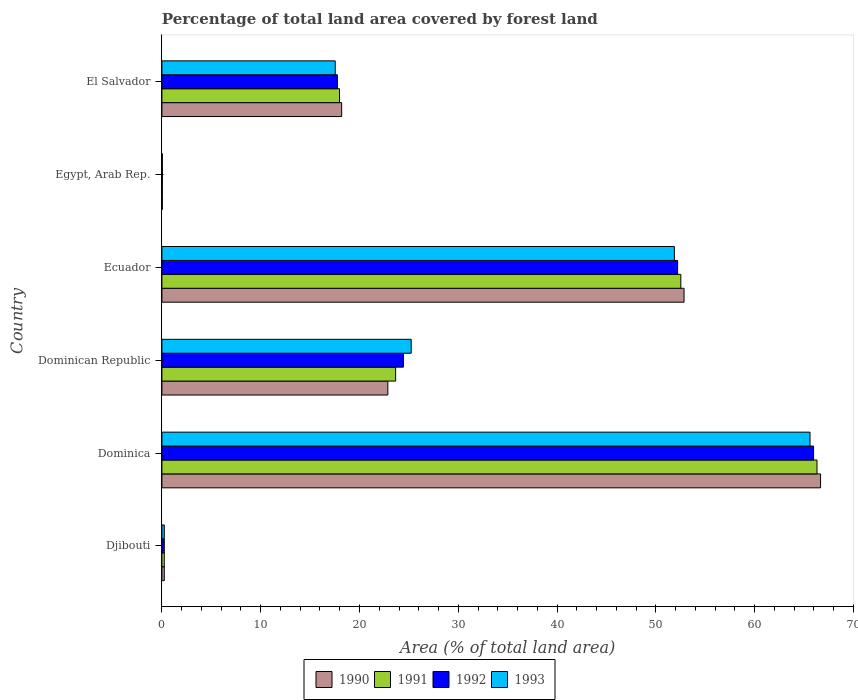How many different coloured bars are there?
Offer a terse response. 4. How many groups of bars are there?
Offer a terse response. 6. Are the number of bars per tick equal to the number of legend labels?
Keep it short and to the point. Yes. How many bars are there on the 4th tick from the top?
Your answer should be very brief. 4. How many bars are there on the 6th tick from the bottom?
Keep it short and to the point. 4. What is the label of the 1st group of bars from the top?
Provide a succinct answer. El Salvador. What is the percentage of forest land in 1990 in El Salvador?
Offer a very short reply. 18.19. Across all countries, what is the maximum percentage of forest land in 1990?
Offer a terse response. 66.67. Across all countries, what is the minimum percentage of forest land in 1993?
Keep it short and to the point. 0.05. In which country was the percentage of forest land in 1990 maximum?
Provide a short and direct response. Dominica. In which country was the percentage of forest land in 1993 minimum?
Your response must be concise. Egypt, Arab Rep. What is the total percentage of forest land in 1993 in the graph?
Offer a very short reply. 160.54. What is the difference between the percentage of forest land in 1993 in Dominican Republic and that in El Salvador?
Your answer should be very brief. 7.69. What is the difference between the percentage of forest land in 1993 in Dominica and the percentage of forest land in 1991 in Ecuador?
Ensure brevity in your answer.  13.08. What is the average percentage of forest land in 1993 per country?
Provide a succinct answer. 26.76. What is the difference between the percentage of forest land in 1991 and percentage of forest land in 1993 in Egypt, Arab Rep.?
Offer a terse response. -0. In how many countries, is the percentage of forest land in 1992 greater than 64 %?
Your response must be concise. 1. What is the ratio of the percentage of forest land in 1993 in Dominican Republic to that in Ecuador?
Offer a terse response. 0.49. Is the difference between the percentage of forest land in 1991 in Djibouti and Egypt, Arab Rep. greater than the difference between the percentage of forest land in 1993 in Djibouti and Egypt, Arab Rep.?
Ensure brevity in your answer.  Yes. What is the difference between the highest and the second highest percentage of forest land in 1991?
Your response must be concise. 13.78. What is the difference between the highest and the lowest percentage of forest land in 1991?
Offer a terse response. 66.26. Is it the case that in every country, the sum of the percentage of forest land in 1991 and percentage of forest land in 1993 is greater than the sum of percentage of forest land in 1990 and percentage of forest land in 1992?
Your response must be concise. No. What does the 3rd bar from the bottom in Dominica represents?
Offer a terse response. 1992. Is it the case that in every country, the sum of the percentage of forest land in 1993 and percentage of forest land in 1992 is greater than the percentage of forest land in 1990?
Your answer should be very brief. Yes. Are all the bars in the graph horizontal?
Your answer should be very brief. Yes. How many countries are there in the graph?
Ensure brevity in your answer.  6. What is the difference between two consecutive major ticks on the X-axis?
Your response must be concise. 10. Does the graph contain any zero values?
Provide a short and direct response. No. Does the graph contain grids?
Offer a very short reply. No. Where does the legend appear in the graph?
Provide a short and direct response. Bottom center. How are the legend labels stacked?
Your response must be concise. Horizontal. What is the title of the graph?
Provide a short and direct response. Percentage of total land area covered by forest land. What is the label or title of the X-axis?
Your answer should be very brief. Area (% of total land area). What is the Area (% of total land area) of 1990 in Djibouti?
Make the answer very short. 0.24. What is the Area (% of total land area) in 1991 in Djibouti?
Your response must be concise. 0.24. What is the Area (% of total land area) in 1992 in Djibouti?
Give a very brief answer. 0.24. What is the Area (% of total land area) of 1993 in Djibouti?
Keep it short and to the point. 0.24. What is the Area (% of total land area) in 1990 in Dominica?
Offer a very short reply. 66.67. What is the Area (% of total land area) in 1991 in Dominica?
Ensure brevity in your answer.  66.31. What is the Area (% of total land area) of 1992 in Dominica?
Your answer should be compact. 65.96. What is the Area (% of total land area) of 1993 in Dominica?
Provide a short and direct response. 65.6. What is the Area (% of total land area) of 1990 in Dominican Republic?
Your answer should be compact. 22.87. What is the Area (% of total land area) of 1991 in Dominican Republic?
Ensure brevity in your answer.  23.66. What is the Area (% of total land area) of 1992 in Dominican Republic?
Your response must be concise. 24.45. What is the Area (% of total land area) of 1993 in Dominican Republic?
Your response must be concise. 25.23. What is the Area (% of total land area) in 1990 in Ecuador?
Your answer should be very brief. 52.85. What is the Area (% of total land area) of 1991 in Ecuador?
Ensure brevity in your answer.  52.52. What is the Area (% of total land area) of 1992 in Ecuador?
Offer a terse response. 52.2. What is the Area (% of total land area) in 1993 in Ecuador?
Your response must be concise. 51.87. What is the Area (% of total land area) of 1990 in Egypt, Arab Rep.?
Make the answer very short. 0.04. What is the Area (% of total land area) of 1991 in Egypt, Arab Rep.?
Make the answer very short. 0.05. What is the Area (% of total land area) in 1992 in Egypt, Arab Rep.?
Your answer should be compact. 0.05. What is the Area (% of total land area) in 1993 in Egypt, Arab Rep.?
Provide a short and direct response. 0.05. What is the Area (% of total land area) of 1990 in El Salvador?
Offer a terse response. 18.19. What is the Area (% of total land area) of 1991 in El Salvador?
Ensure brevity in your answer.  17.98. What is the Area (% of total land area) in 1992 in El Salvador?
Offer a very short reply. 17.76. What is the Area (% of total land area) of 1993 in El Salvador?
Your answer should be compact. 17.54. Across all countries, what is the maximum Area (% of total land area) in 1990?
Your response must be concise. 66.67. Across all countries, what is the maximum Area (% of total land area) of 1991?
Keep it short and to the point. 66.31. Across all countries, what is the maximum Area (% of total land area) in 1992?
Your answer should be compact. 65.96. Across all countries, what is the maximum Area (% of total land area) of 1993?
Ensure brevity in your answer.  65.6. Across all countries, what is the minimum Area (% of total land area) of 1990?
Your answer should be very brief. 0.04. Across all countries, what is the minimum Area (% of total land area) in 1991?
Give a very brief answer. 0.05. Across all countries, what is the minimum Area (% of total land area) of 1992?
Keep it short and to the point. 0.05. Across all countries, what is the minimum Area (% of total land area) in 1993?
Provide a short and direct response. 0.05. What is the total Area (% of total land area) of 1990 in the graph?
Give a very brief answer. 160.87. What is the total Area (% of total land area) in 1991 in the graph?
Provide a short and direct response. 160.75. What is the total Area (% of total land area) in 1992 in the graph?
Your answer should be compact. 160.65. What is the total Area (% of total land area) of 1993 in the graph?
Ensure brevity in your answer.  160.54. What is the difference between the Area (% of total land area) of 1990 in Djibouti and that in Dominica?
Your response must be concise. -66.43. What is the difference between the Area (% of total land area) in 1991 in Djibouti and that in Dominica?
Provide a succinct answer. -66.07. What is the difference between the Area (% of total land area) in 1992 in Djibouti and that in Dominica?
Make the answer very short. -65.72. What is the difference between the Area (% of total land area) of 1993 in Djibouti and that in Dominica?
Make the answer very short. -65.36. What is the difference between the Area (% of total land area) of 1990 in Djibouti and that in Dominican Republic?
Make the answer very short. -22.63. What is the difference between the Area (% of total land area) in 1991 in Djibouti and that in Dominican Republic?
Provide a short and direct response. -23.42. What is the difference between the Area (% of total land area) of 1992 in Djibouti and that in Dominican Republic?
Keep it short and to the point. -24.2. What is the difference between the Area (% of total land area) in 1993 in Djibouti and that in Dominican Republic?
Ensure brevity in your answer.  -24.99. What is the difference between the Area (% of total land area) of 1990 in Djibouti and that in Ecuador?
Your response must be concise. -52.61. What is the difference between the Area (% of total land area) of 1991 in Djibouti and that in Ecuador?
Keep it short and to the point. -52.28. What is the difference between the Area (% of total land area) of 1992 in Djibouti and that in Ecuador?
Offer a terse response. -51.96. What is the difference between the Area (% of total land area) of 1993 in Djibouti and that in Ecuador?
Your response must be concise. -51.63. What is the difference between the Area (% of total land area) in 1990 in Djibouti and that in Egypt, Arab Rep.?
Your answer should be compact. 0.2. What is the difference between the Area (% of total land area) of 1991 in Djibouti and that in Egypt, Arab Rep.?
Provide a short and direct response. 0.2. What is the difference between the Area (% of total land area) of 1992 in Djibouti and that in Egypt, Arab Rep.?
Provide a short and direct response. 0.19. What is the difference between the Area (% of total land area) of 1993 in Djibouti and that in Egypt, Arab Rep.?
Provide a succinct answer. 0.19. What is the difference between the Area (% of total land area) in 1990 in Djibouti and that in El Salvador?
Your answer should be compact. -17.95. What is the difference between the Area (% of total land area) in 1991 in Djibouti and that in El Salvador?
Provide a short and direct response. -17.74. What is the difference between the Area (% of total land area) in 1992 in Djibouti and that in El Salvador?
Keep it short and to the point. -17.52. What is the difference between the Area (% of total land area) of 1993 in Djibouti and that in El Salvador?
Ensure brevity in your answer.  -17.3. What is the difference between the Area (% of total land area) in 1990 in Dominica and that in Dominican Republic?
Ensure brevity in your answer.  43.8. What is the difference between the Area (% of total land area) of 1991 in Dominica and that in Dominican Republic?
Your answer should be compact. 42.65. What is the difference between the Area (% of total land area) in 1992 in Dominica and that in Dominican Republic?
Provide a short and direct response. 41.51. What is the difference between the Area (% of total land area) of 1993 in Dominica and that in Dominican Republic?
Provide a succinct answer. 40.37. What is the difference between the Area (% of total land area) of 1990 in Dominica and that in Ecuador?
Give a very brief answer. 13.82. What is the difference between the Area (% of total land area) in 1991 in Dominica and that in Ecuador?
Provide a succinct answer. 13.78. What is the difference between the Area (% of total land area) of 1992 in Dominica and that in Ecuador?
Provide a succinct answer. 13.76. What is the difference between the Area (% of total land area) in 1993 in Dominica and that in Ecuador?
Keep it short and to the point. 13.73. What is the difference between the Area (% of total land area) in 1990 in Dominica and that in Egypt, Arab Rep.?
Keep it short and to the point. 66.62. What is the difference between the Area (% of total land area) of 1991 in Dominica and that in Egypt, Arab Rep.?
Make the answer very short. 66.26. What is the difference between the Area (% of total land area) in 1992 in Dominica and that in Egypt, Arab Rep.?
Keep it short and to the point. 65.91. What is the difference between the Area (% of total land area) of 1993 in Dominica and that in Egypt, Arab Rep.?
Offer a very short reply. 65.55. What is the difference between the Area (% of total land area) of 1990 in Dominica and that in El Salvador?
Provide a short and direct response. 48.47. What is the difference between the Area (% of total land area) in 1991 in Dominica and that in El Salvador?
Your response must be concise. 48.33. What is the difference between the Area (% of total land area) of 1992 in Dominica and that in El Salvador?
Provide a succinct answer. 48.2. What is the difference between the Area (% of total land area) in 1993 in Dominica and that in El Salvador?
Make the answer very short. 48.06. What is the difference between the Area (% of total land area) of 1990 in Dominican Republic and that in Ecuador?
Your answer should be compact. -29.98. What is the difference between the Area (% of total land area) in 1991 in Dominican Republic and that in Ecuador?
Keep it short and to the point. -28.87. What is the difference between the Area (% of total land area) in 1992 in Dominican Republic and that in Ecuador?
Provide a short and direct response. -27.75. What is the difference between the Area (% of total land area) in 1993 in Dominican Republic and that in Ecuador?
Your answer should be very brief. -26.64. What is the difference between the Area (% of total land area) in 1990 in Dominican Republic and that in Egypt, Arab Rep.?
Give a very brief answer. 22.82. What is the difference between the Area (% of total land area) in 1991 in Dominican Republic and that in Egypt, Arab Rep.?
Offer a terse response. 23.61. What is the difference between the Area (% of total land area) of 1992 in Dominican Republic and that in Egypt, Arab Rep.?
Ensure brevity in your answer.  24.4. What is the difference between the Area (% of total land area) in 1993 in Dominican Republic and that in Egypt, Arab Rep.?
Provide a succinct answer. 25.19. What is the difference between the Area (% of total land area) in 1990 in Dominican Republic and that in El Salvador?
Offer a very short reply. 4.67. What is the difference between the Area (% of total land area) of 1991 in Dominican Republic and that in El Salvador?
Provide a succinct answer. 5.68. What is the difference between the Area (% of total land area) of 1992 in Dominican Republic and that in El Salvador?
Your answer should be very brief. 6.68. What is the difference between the Area (% of total land area) of 1993 in Dominican Republic and that in El Salvador?
Your answer should be compact. 7.69. What is the difference between the Area (% of total land area) in 1990 in Ecuador and that in Egypt, Arab Rep.?
Offer a very short reply. 52.81. What is the difference between the Area (% of total land area) of 1991 in Ecuador and that in Egypt, Arab Rep.?
Give a very brief answer. 52.48. What is the difference between the Area (% of total land area) in 1992 in Ecuador and that in Egypt, Arab Rep.?
Make the answer very short. 52.15. What is the difference between the Area (% of total land area) in 1993 in Ecuador and that in Egypt, Arab Rep.?
Offer a terse response. 51.82. What is the difference between the Area (% of total land area) of 1990 in Ecuador and that in El Salvador?
Provide a succinct answer. 34.65. What is the difference between the Area (% of total land area) of 1991 in Ecuador and that in El Salvador?
Offer a terse response. 34.55. What is the difference between the Area (% of total land area) in 1992 in Ecuador and that in El Salvador?
Your response must be concise. 34.44. What is the difference between the Area (% of total land area) in 1993 in Ecuador and that in El Salvador?
Your answer should be compact. 34.33. What is the difference between the Area (% of total land area) in 1990 in Egypt, Arab Rep. and that in El Salvador?
Provide a succinct answer. -18.15. What is the difference between the Area (% of total land area) of 1991 in Egypt, Arab Rep. and that in El Salvador?
Your response must be concise. -17.93. What is the difference between the Area (% of total land area) in 1992 in Egypt, Arab Rep. and that in El Salvador?
Offer a terse response. -17.71. What is the difference between the Area (% of total land area) of 1993 in Egypt, Arab Rep. and that in El Salvador?
Your response must be concise. -17.49. What is the difference between the Area (% of total land area) of 1990 in Djibouti and the Area (% of total land area) of 1991 in Dominica?
Offer a very short reply. -66.07. What is the difference between the Area (% of total land area) of 1990 in Djibouti and the Area (% of total land area) of 1992 in Dominica?
Offer a very short reply. -65.72. What is the difference between the Area (% of total land area) in 1990 in Djibouti and the Area (% of total land area) in 1993 in Dominica?
Ensure brevity in your answer.  -65.36. What is the difference between the Area (% of total land area) in 1991 in Djibouti and the Area (% of total land area) in 1992 in Dominica?
Your answer should be very brief. -65.72. What is the difference between the Area (% of total land area) in 1991 in Djibouti and the Area (% of total land area) in 1993 in Dominica?
Your answer should be very brief. -65.36. What is the difference between the Area (% of total land area) in 1992 in Djibouti and the Area (% of total land area) in 1993 in Dominica?
Your answer should be compact. -65.36. What is the difference between the Area (% of total land area) of 1990 in Djibouti and the Area (% of total land area) of 1991 in Dominican Republic?
Offer a terse response. -23.42. What is the difference between the Area (% of total land area) in 1990 in Djibouti and the Area (% of total land area) in 1992 in Dominican Republic?
Make the answer very short. -24.2. What is the difference between the Area (% of total land area) of 1990 in Djibouti and the Area (% of total land area) of 1993 in Dominican Republic?
Your answer should be compact. -24.99. What is the difference between the Area (% of total land area) of 1991 in Djibouti and the Area (% of total land area) of 1992 in Dominican Republic?
Make the answer very short. -24.2. What is the difference between the Area (% of total land area) in 1991 in Djibouti and the Area (% of total land area) in 1993 in Dominican Republic?
Keep it short and to the point. -24.99. What is the difference between the Area (% of total land area) in 1992 in Djibouti and the Area (% of total land area) in 1993 in Dominican Republic?
Ensure brevity in your answer.  -24.99. What is the difference between the Area (% of total land area) in 1990 in Djibouti and the Area (% of total land area) in 1991 in Ecuador?
Keep it short and to the point. -52.28. What is the difference between the Area (% of total land area) in 1990 in Djibouti and the Area (% of total land area) in 1992 in Ecuador?
Provide a short and direct response. -51.96. What is the difference between the Area (% of total land area) in 1990 in Djibouti and the Area (% of total land area) in 1993 in Ecuador?
Your answer should be compact. -51.63. What is the difference between the Area (% of total land area) of 1991 in Djibouti and the Area (% of total land area) of 1992 in Ecuador?
Keep it short and to the point. -51.96. What is the difference between the Area (% of total land area) of 1991 in Djibouti and the Area (% of total land area) of 1993 in Ecuador?
Ensure brevity in your answer.  -51.63. What is the difference between the Area (% of total land area) in 1992 in Djibouti and the Area (% of total land area) in 1993 in Ecuador?
Offer a very short reply. -51.63. What is the difference between the Area (% of total land area) of 1990 in Djibouti and the Area (% of total land area) of 1991 in Egypt, Arab Rep.?
Provide a short and direct response. 0.2. What is the difference between the Area (% of total land area) in 1990 in Djibouti and the Area (% of total land area) in 1992 in Egypt, Arab Rep.?
Offer a terse response. 0.19. What is the difference between the Area (% of total land area) of 1990 in Djibouti and the Area (% of total land area) of 1993 in Egypt, Arab Rep.?
Keep it short and to the point. 0.19. What is the difference between the Area (% of total land area) of 1991 in Djibouti and the Area (% of total land area) of 1992 in Egypt, Arab Rep.?
Provide a short and direct response. 0.19. What is the difference between the Area (% of total land area) of 1991 in Djibouti and the Area (% of total land area) of 1993 in Egypt, Arab Rep.?
Your answer should be compact. 0.19. What is the difference between the Area (% of total land area) of 1992 in Djibouti and the Area (% of total land area) of 1993 in Egypt, Arab Rep.?
Give a very brief answer. 0.19. What is the difference between the Area (% of total land area) of 1990 in Djibouti and the Area (% of total land area) of 1991 in El Salvador?
Keep it short and to the point. -17.74. What is the difference between the Area (% of total land area) of 1990 in Djibouti and the Area (% of total land area) of 1992 in El Salvador?
Ensure brevity in your answer.  -17.52. What is the difference between the Area (% of total land area) of 1990 in Djibouti and the Area (% of total land area) of 1993 in El Salvador?
Offer a very short reply. -17.3. What is the difference between the Area (% of total land area) of 1991 in Djibouti and the Area (% of total land area) of 1992 in El Salvador?
Provide a short and direct response. -17.52. What is the difference between the Area (% of total land area) in 1991 in Djibouti and the Area (% of total land area) in 1993 in El Salvador?
Provide a short and direct response. -17.3. What is the difference between the Area (% of total land area) of 1992 in Djibouti and the Area (% of total land area) of 1993 in El Salvador?
Your answer should be compact. -17.3. What is the difference between the Area (% of total land area) of 1990 in Dominica and the Area (% of total land area) of 1991 in Dominican Republic?
Provide a succinct answer. 43.01. What is the difference between the Area (% of total land area) in 1990 in Dominica and the Area (% of total land area) in 1992 in Dominican Republic?
Give a very brief answer. 42.22. What is the difference between the Area (% of total land area) of 1990 in Dominica and the Area (% of total land area) of 1993 in Dominican Republic?
Offer a very short reply. 41.43. What is the difference between the Area (% of total land area) of 1991 in Dominica and the Area (% of total land area) of 1992 in Dominican Republic?
Make the answer very short. 41.86. What is the difference between the Area (% of total land area) of 1991 in Dominica and the Area (% of total land area) of 1993 in Dominican Republic?
Keep it short and to the point. 41.07. What is the difference between the Area (% of total land area) in 1992 in Dominica and the Area (% of total land area) in 1993 in Dominican Republic?
Give a very brief answer. 40.73. What is the difference between the Area (% of total land area) of 1990 in Dominica and the Area (% of total land area) of 1991 in Ecuador?
Make the answer very short. 14.14. What is the difference between the Area (% of total land area) in 1990 in Dominica and the Area (% of total land area) in 1992 in Ecuador?
Offer a terse response. 14.47. What is the difference between the Area (% of total land area) in 1990 in Dominica and the Area (% of total land area) in 1993 in Ecuador?
Ensure brevity in your answer.  14.79. What is the difference between the Area (% of total land area) in 1991 in Dominica and the Area (% of total land area) in 1992 in Ecuador?
Offer a very short reply. 14.11. What is the difference between the Area (% of total land area) of 1991 in Dominica and the Area (% of total land area) of 1993 in Ecuador?
Your answer should be compact. 14.43. What is the difference between the Area (% of total land area) of 1992 in Dominica and the Area (% of total land area) of 1993 in Ecuador?
Provide a short and direct response. 14.09. What is the difference between the Area (% of total land area) in 1990 in Dominica and the Area (% of total land area) in 1991 in Egypt, Arab Rep.?
Your response must be concise. 66.62. What is the difference between the Area (% of total land area) in 1990 in Dominica and the Area (% of total land area) in 1992 in Egypt, Arab Rep.?
Your answer should be very brief. 66.62. What is the difference between the Area (% of total land area) of 1990 in Dominica and the Area (% of total land area) of 1993 in Egypt, Arab Rep.?
Give a very brief answer. 66.62. What is the difference between the Area (% of total land area) of 1991 in Dominica and the Area (% of total land area) of 1992 in Egypt, Arab Rep.?
Ensure brevity in your answer.  66.26. What is the difference between the Area (% of total land area) of 1991 in Dominica and the Area (% of total land area) of 1993 in Egypt, Arab Rep.?
Keep it short and to the point. 66.26. What is the difference between the Area (% of total land area) of 1992 in Dominica and the Area (% of total land area) of 1993 in Egypt, Arab Rep.?
Provide a succinct answer. 65.91. What is the difference between the Area (% of total land area) in 1990 in Dominica and the Area (% of total land area) in 1991 in El Salvador?
Offer a terse response. 48.69. What is the difference between the Area (% of total land area) in 1990 in Dominica and the Area (% of total land area) in 1992 in El Salvador?
Give a very brief answer. 48.91. What is the difference between the Area (% of total land area) of 1990 in Dominica and the Area (% of total land area) of 1993 in El Salvador?
Offer a very short reply. 49.12. What is the difference between the Area (% of total land area) of 1991 in Dominica and the Area (% of total land area) of 1992 in El Salvador?
Offer a terse response. 48.55. What is the difference between the Area (% of total land area) of 1991 in Dominica and the Area (% of total land area) of 1993 in El Salvador?
Ensure brevity in your answer.  48.76. What is the difference between the Area (% of total land area) in 1992 in Dominica and the Area (% of total land area) in 1993 in El Salvador?
Offer a very short reply. 48.42. What is the difference between the Area (% of total land area) in 1990 in Dominican Republic and the Area (% of total land area) in 1991 in Ecuador?
Ensure brevity in your answer.  -29.66. What is the difference between the Area (% of total land area) of 1990 in Dominican Republic and the Area (% of total land area) of 1992 in Ecuador?
Your answer should be very brief. -29.33. What is the difference between the Area (% of total land area) in 1990 in Dominican Republic and the Area (% of total land area) in 1993 in Ecuador?
Your answer should be very brief. -29. What is the difference between the Area (% of total land area) of 1991 in Dominican Republic and the Area (% of total land area) of 1992 in Ecuador?
Your response must be concise. -28.54. What is the difference between the Area (% of total land area) in 1991 in Dominican Republic and the Area (% of total land area) in 1993 in Ecuador?
Ensure brevity in your answer.  -28.22. What is the difference between the Area (% of total land area) in 1992 in Dominican Republic and the Area (% of total land area) in 1993 in Ecuador?
Give a very brief answer. -27.43. What is the difference between the Area (% of total land area) in 1990 in Dominican Republic and the Area (% of total land area) in 1991 in Egypt, Arab Rep.?
Your answer should be compact. 22.82. What is the difference between the Area (% of total land area) of 1990 in Dominican Republic and the Area (% of total land area) of 1992 in Egypt, Arab Rep.?
Offer a terse response. 22.82. What is the difference between the Area (% of total land area) of 1990 in Dominican Republic and the Area (% of total land area) of 1993 in Egypt, Arab Rep.?
Keep it short and to the point. 22.82. What is the difference between the Area (% of total land area) in 1991 in Dominican Republic and the Area (% of total land area) in 1992 in Egypt, Arab Rep.?
Your answer should be very brief. 23.61. What is the difference between the Area (% of total land area) in 1991 in Dominican Republic and the Area (% of total land area) in 1993 in Egypt, Arab Rep.?
Offer a very short reply. 23.61. What is the difference between the Area (% of total land area) of 1992 in Dominican Republic and the Area (% of total land area) of 1993 in Egypt, Arab Rep.?
Give a very brief answer. 24.4. What is the difference between the Area (% of total land area) of 1990 in Dominican Republic and the Area (% of total land area) of 1991 in El Salvador?
Ensure brevity in your answer.  4.89. What is the difference between the Area (% of total land area) of 1990 in Dominican Republic and the Area (% of total land area) of 1992 in El Salvador?
Offer a terse response. 5.11. What is the difference between the Area (% of total land area) of 1990 in Dominican Republic and the Area (% of total land area) of 1993 in El Salvador?
Give a very brief answer. 5.32. What is the difference between the Area (% of total land area) of 1991 in Dominican Republic and the Area (% of total land area) of 1992 in El Salvador?
Keep it short and to the point. 5.9. What is the difference between the Area (% of total land area) of 1991 in Dominican Republic and the Area (% of total land area) of 1993 in El Salvador?
Provide a succinct answer. 6.11. What is the difference between the Area (% of total land area) of 1992 in Dominican Republic and the Area (% of total land area) of 1993 in El Salvador?
Offer a terse response. 6.9. What is the difference between the Area (% of total land area) of 1990 in Ecuador and the Area (% of total land area) of 1991 in Egypt, Arab Rep.?
Your answer should be very brief. 52.8. What is the difference between the Area (% of total land area) of 1990 in Ecuador and the Area (% of total land area) of 1992 in Egypt, Arab Rep.?
Your answer should be compact. 52.8. What is the difference between the Area (% of total land area) of 1990 in Ecuador and the Area (% of total land area) of 1993 in Egypt, Arab Rep.?
Offer a terse response. 52.8. What is the difference between the Area (% of total land area) in 1991 in Ecuador and the Area (% of total land area) in 1992 in Egypt, Arab Rep.?
Provide a short and direct response. 52.48. What is the difference between the Area (% of total land area) of 1991 in Ecuador and the Area (% of total land area) of 1993 in Egypt, Arab Rep.?
Offer a very short reply. 52.47. What is the difference between the Area (% of total land area) in 1992 in Ecuador and the Area (% of total land area) in 1993 in Egypt, Arab Rep.?
Provide a succinct answer. 52.15. What is the difference between the Area (% of total land area) in 1990 in Ecuador and the Area (% of total land area) in 1991 in El Salvador?
Your response must be concise. 34.87. What is the difference between the Area (% of total land area) of 1990 in Ecuador and the Area (% of total land area) of 1992 in El Salvador?
Ensure brevity in your answer.  35.09. What is the difference between the Area (% of total land area) of 1990 in Ecuador and the Area (% of total land area) of 1993 in El Salvador?
Provide a short and direct response. 35.31. What is the difference between the Area (% of total land area) in 1991 in Ecuador and the Area (% of total land area) in 1992 in El Salvador?
Your answer should be compact. 34.76. What is the difference between the Area (% of total land area) in 1991 in Ecuador and the Area (% of total land area) in 1993 in El Salvador?
Provide a succinct answer. 34.98. What is the difference between the Area (% of total land area) of 1992 in Ecuador and the Area (% of total land area) of 1993 in El Salvador?
Your answer should be compact. 34.65. What is the difference between the Area (% of total land area) in 1990 in Egypt, Arab Rep. and the Area (% of total land area) in 1991 in El Salvador?
Your answer should be very brief. -17.93. What is the difference between the Area (% of total land area) in 1990 in Egypt, Arab Rep. and the Area (% of total land area) in 1992 in El Salvador?
Offer a very short reply. -17.72. What is the difference between the Area (% of total land area) in 1990 in Egypt, Arab Rep. and the Area (% of total land area) in 1993 in El Salvador?
Keep it short and to the point. -17.5. What is the difference between the Area (% of total land area) in 1991 in Egypt, Arab Rep. and the Area (% of total land area) in 1992 in El Salvador?
Make the answer very short. -17.71. What is the difference between the Area (% of total land area) of 1991 in Egypt, Arab Rep. and the Area (% of total land area) of 1993 in El Salvador?
Offer a very short reply. -17.5. What is the difference between the Area (% of total land area) in 1992 in Egypt, Arab Rep. and the Area (% of total land area) in 1993 in El Salvador?
Ensure brevity in your answer.  -17.5. What is the average Area (% of total land area) in 1990 per country?
Offer a very short reply. 26.81. What is the average Area (% of total land area) of 1991 per country?
Offer a terse response. 26.79. What is the average Area (% of total land area) in 1992 per country?
Make the answer very short. 26.78. What is the average Area (% of total land area) of 1993 per country?
Ensure brevity in your answer.  26.76. What is the difference between the Area (% of total land area) of 1990 and Area (% of total land area) of 1991 in Djibouti?
Ensure brevity in your answer.  0. What is the difference between the Area (% of total land area) in 1990 and Area (% of total land area) in 1993 in Djibouti?
Your answer should be very brief. 0. What is the difference between the Area (% of total land area) in 1990 and Area (% of total land area) in 1991 in Dominica?
Ensure brevity in your answer.  0.36. What is the difference between the Area (% of total land area) in 1990 and Area (% of total land area) in 1992 in Dominica?
Keep it short and to the point. 0.71. What is the difference between the Area (% of total land area) of 1990 and Area (% of total land area) of 1993 in Dominica?
Ensure brevity in your answer.  1.07. What is the difference between the Area (% of total land area) of 1991 and Area (% of total land area) of 1992 in Dominica?
Your answer should be very brief. 0.35. What is the difference between the Area (% of total land area) in 1991 and Area (% of total land area) in 1993 in Dominica?
Ensure brevity in your answer.  0.71. What is the difference between the Area (% of total land area) of 1992 and Area (% of total land area) of 1993 in Dominica?
Make the answer very short. 0.36. What is the difference between the Area (% of total land area) of 1990 and Area (% of total land area) of 1991 in Dominican Republic?
Your response must be concise. -0.79. What is the difference between the Area (% of total land area) in 1990 and Area (% of total land area) in 1992 in Dominican Republic?
Offer a terse response. -1.58. What is the difference between the Area (% of total land area) in 1990 and Area (% of total land area) in 1993 in Dominican Republic?
Provide a succinct answer. -2.37. What is the difference between the Area (% of total land area) in 1991 and Area (% of total land area) in 1992 in Dominican Republic?
Offer a very short reply. -0.79. What is the difference between the Area (% of total land area) in 1991 and Area (% of total land area) in 1993 in Dominican Republic?
Provide a short and direct response. -1.58. What is the difference between the Area (% of total land area) in 1992 and Area (% of total land area) in 1993 in Dominican Republic?
Your answer should be compact. -0.79. What is the difference between the Area (% of total land area) in 1990 and Area (% of total land area) in 1991 in Ecuador?
Offer a terse response. 0.33. What is the difference between the Area (% of total land area) of 1990 and Area (% of total land area) of 1992 in Ecuador?
Your response must be concise. 0.65. What is the difference between the Area (% of total land area) of 1990 and Area (% of total land area) of 1993 in Ecuador?
Make the answer very short. 0.98. What is the difference between the Area (% of total land area) in 1991 and Area (% of total land area) in 1992 in Ecuador?
Ensure brevity in your answer.  0.33. What is the difference between the Area (% of total land area) in 1991 and Area (% of total land area) in 1993 in Ecuador?
Keep it short and to the point. 0.65. What is the difference between the Area (% of total land area) of 1992 and Area (% of total land area) of 1993 in Ecuador?
Ensure brevity in your answer.  0.33. What is the difference between the Area (% of total land area) in 1990 and Area (% of total land area) in 1991 in Egypt, Arab Rep.?
Offer a terse response. -0. What is the difference between the Area (% of total land area) in 1990 and Area (% of total land area) in 1992 in Egypt, Arab Rep.?
Make the answer very short. -0. What is the difference between the Area (% of total land area) in 1990 and Area (% of total land area) in 1993 in Egypt, Arab Rep.?
Give a very brief answer. -0. What is the difference between the Area (% of total land area) of 1991 and Area (% of total land area) of 1992 in Egypt, Arab Rep.?
Make the answer very short. -0. What is the difference between the Area (% of total land area) in 1991 and Area (% of total land area) in 1993 in Egypt, Arab Rep.?
Give a very brief answer. -0. What is the difference between the Area (% of total land area) in 1992 and Area (% of total land area) in 1993 in Egypt, Arab Rep.?
Ensure brevity in your answer.  -0. What is the difference between the Area (% of total land area) of 1990 and Area (% of total land area) of 1991 in El Salvador?
Your response must be concise. 0.22. What is the difference between the Area (% of total land area) in 1990 and Area (% of total land area) in 1992 in El Salvador?
Your response must be concise. 0.43. What is the difference between the Area (% of total land area) in 1990 and Area (% of total land area) in 1993 in El Salvador?
Provide a short and direct response. 0.65. What is the difference between the Area (% of total land area) of 1991 and Area (% of total land area) of 1992 in El Salvador?
Your response must be concise. 0.22. What is the difference between the Area (% of total land area) of 1991 and Area (% of total land area) of 1993 in El Salvador?
Your response must be concise. 0.43. What is the difference between the Area (% of total land area) in 1992 and Area (% of total land area) in 1993 in El Salvador?
Offer a very short reply. 0.22. What is the ratio of the Area (% of total land area) in 1990 in Djibouti to that in Dominica?
Provide a short and direct response. 0. What is the ratio of the Area (% of total land area) in 1991 in Djibouti to that in Dominica?
Keep it short and to the point. 0. What is the ratio of the Area (% of total land area) in 1992 in Djibouti to that in Dominica?
Give a very brief answer. 0. What is the ratio of the Area (% of total land area) in 1993 in Djibouti to that in Dominica?
Provide a succinct answer. 0. What is the ratio of the Area (% of total land area) of 1990 in Djibouti to that in Dominican Republic?
Ensure brevity in your answer.  0.01. What is the ratio of the Area (% of total land area) in 1991 in Djibouti to that in Dominican Republic?
Provide a succinct answer. 0.01. What is the ratio of the Area (% of total land area) in 1992 in Djibouti to that in Dominican Republic?
Your answer should be very brief. 0.01. What is the ratio of the Area (% of total land area) of 1993 in Djibouti to that in Dominican Republic?
Offer a terse response. 0.01. What is the ratio of the Area (% of total land area) of 1990 in Djibouti to that in Ecuador?
Your answer should be compact. 0. What is the ratio of the Area (% of total land area) of 1991 in Djibouti to that in Ecuador?
Give a very brief answer. 0. What is the ratio of the Area (% of total land area) of 1992 in Djibouti to that in Ecuador?
Provide a short and direct response. 0. What is the ratio of the Area (% of total land area) of 1993 in Djibouti to that in Ecuador?
Ensure brevity in your answer.  0. What is the ratio of the Area (% of total land area) of 1990 in Djibouti to that in Egypt, Arab Rep.?
Make the answer very short. 5.47. What is the ratio of the Area (% of total land area) in 1991 in Djibouti to that in Egypt, Arab Rep.?
Give a very brief answer. 5.29. What is the ratio of the Area (% of total land area) of 1992 in Djibouti to that in Egypt, Arab Rep.?
Provide a short and direct response. 5.12. What is the ratio of the Area (% of total land area) in 1993 in Djibouti to that in Egypt, Arab Rep.?
Keep it short and to the point. 4.96. What is the ratio of the Area (% of total land area) in 1990 in Djibouti to that in El Salvador?
Keep it short and to the point. 0.01. What is the ratio of the Area (% of total land area) in 1991 in Djibouti to that in El Salvador?
Ensure brevity in your answer.  0.01. What is the ratio of the Area (% of total land area) of 1992 in Djibouti to that in El Salvador?
Offer a terse response. 0.01. What is the ratio of the Area (% of total land area) in 1993 in Djibouti to that in El Salvador?
Make the answer very short. 0.01. What is the ratio of the Area (% of total land area) of 1990 in Dominica to that in Dominican Republic?
Your answer should be compact. 2.92. What is the ratio of the Area (% of total land area) in 1991 in Dominica to that in Dominican Republic?
Provide a succinct answer. 2.8. What is the ratio of the Area (% of total land area) in 1992 in Dominica to that in Dominican Republic?
Ensure brevity in your answer.  2.7. What is the ratio of the Area (% of total land area) of 1993 in Dominica to that in Dominican Republic?
Your answer should be very brief. 2.6. What is the ratio of the Area (% of total land area) in 1990 in Dominica to that in Ecuador?
Offer a terse response. 1.26. What is the ratio of the Area (% of total land area) of 1991 in Dominica to that in Ecuador?
Offer a very short reply. 1.26. What is the ratio of the Area (% of total land area) in 1992 in Dominica to that in Ecuador?
Give a very brief answer. 1.26. What is the ratio of the Area (% of total land area) in 1993 in Dominica to that in Ecuador?
Your answer should be compact. 1.26. What is the ratio of the Area (% of total land area) of 1990 in Dominica to that in Egypt, Arab Rep.?
Your answer should be very brief. 1508.26. What is the ratio of the Area (% of total land area) in 1991 in Dominica to that in Egypt, Arab Rep.?
Your response must be concise. 1450.66. What is the ratio of the Area (% of total land area) of 1992 in Dominica to that in Egypt, Arab Rep.?
Give a very brief answer. 1397.02. What is the ratio of the Area (% of total land area) in 1993 in Dominica to that in Egypt, Arab Rep.?
Ensure brevity in your answer.  1346.42. What is the ratio of the Area (% of total land area) in 1990 in Dominica to that in El Salvador?
Offer a terse response. 3.66. What is the ratio of the Area (% of total land area) in 1991 in Dominica to that in El Salvador?
Give a very brief answer. 3.69. What is the ratio of the Area (% of total land area) of 1992 in Dominica to that in El Salvador?
Give a very brief answer. 3.71. What is the ratio of the Area (% of total land area) of 1993 in Dominica to that in El Salvador?
Offer a terse response. 3.74. What is the ratio of the Area (% of total land area) in 1990 in Dominican Republic to that in Ecuador?
Your answer should be compact. 0.43. What is the ratio of the Area (% of total land area) in 1991 in Dominican Republic to that in Ecuador?
Keep it short and to the point. 0.45. What is the ratio of the Area (% of total land area) of 1992 in Dominican Republic to that in Ecuador?
Provide a succinct answer. 0.47. What is the ratio of the Area (% of total land area) of 1993 in Dominican Republic to that in Ecuador?
Provide a short and direct response. 0.49. What is the ratio of the Area (% of total land area) in 1990 in Dominican Republic to that in Egypt, Arab Rep.?
Keep it short and to the point. 517.37. What is the ratio of the Area (% of total land area) in 1991 in Dominican Republic to that in Egypt, Arab Rep.?
Provide a succinct answer. 517.57. What is the ratio of the Area (% of total land area) of 1992 in Dominican Republic to that in Egypt, Arab Rep.?
Your answer should be compact. 517.75. What is the ratio of the Area (% of total land area) of 1993 in Dominican Republic to that in Egypt, Arab Rep.?
Your answer should be compact. 517.92. What is the ratio of the Area (% of total land area) in 1990 in Dominican Republic to that in El Salvador?
Provide a short and direct response. 1.26. What is the ratio of the Area (% of total land area) of 1991 in Dominican Republic to that in El Salvador?
Make the answer very short. 1.32. What is the ratio of the Area (% of total land area) of 1992 in Dominican Republic to that in El Salvador?
Offer a very short reply. 1.38. What is the ratio of the Area (% of total land area) of 1993 in Dominican Republic to that in El Salvador?
Your answer should be compact. 1.44. What is the ratio of the Area (% of total land area) of 1990 in Ecuador to that in Egypt, Arab Rep.?
Provide a succinct answer. 1195.66. What is the ratio of the Area (% of total land area) in 1991 in Ecuador to that in Egypt, Arab Rep.?
Give a very brief answer. 1149.11. What is the ratio of the Area (% of total land area) of 1992 in Ecuador to that in Egypt, Arab Rep.?
Offer a terse response. 1105.54. What is the ratio of the Area (% of total land area) of 1993 in Ecuador to that in Egypt, Arab Rep.?
Your answer should be compact. 1064.66. What is the ratio of the Area (% of total land area) of 1990 in Ecuador to that in El Salvador?
Give a very brief answer. 2.9. What is the ratio of the Area (% of total land area) in 1991 in Ecuador to that in El Salvador?
Provide a succinct answer. 2.92. What is the ratio of the Area (% of total land area) of 1992 in Ecuador to that in El Salvador?
Offer a terse response. 2.94. What is the ratio of the Area (% of total land area) in 1993 in Ecuador to that in El Salvador?
Your answer should be very brief. 2.96. What is the ratio of the Area (% of total land area) of 1990 in Egypt, Arab Rep. to that in El Salvador?
Keep it short and to the point. 0. What is the ratio of the Area (% of total land area) of 1991 in Egypt, Arab Rep. to that in El Salvador?
Provide a succinct answer. 0. What is the ratio of the Area (% of total land area) of 1992 in Egypt, Arab Rep. to that in El Salvador?
Provide a succinct answer. 0. What is the ratio of the Area (% of total land area) in 1993 in Egypt, Arab Rep. to that in El Salvador?
Provide a short and direct response. 0. What is the difference between the highest and the second highest Area (% of total land area) of 1990?
Your answer should be very brief. 13.82. What is the difference between the highest and the second highest Area (% of total land area) of 1991?
Give a very brief answer. 13.78. What is the difference between the highest and the second highest Area (% of total land area) of 1992?
Provide a succinct answer. 13.76. What is the difference between the highest and the second highest Area (% of total land area) in 1993?
Your answer should be compact. 13.73. What is the difference between the highest and the lowest Area (% of total land area) of 1990?
Give a very brief answer. 66.62. What is the difference between the highest and the lowest Area (% of total land area) of 1991?
Your response must be concise. 66.26. What is the difference between the highest and the lowest Area (% of total land area) of 1992?
Provide a short and direct response. 65.91. What is the difference between the highest and the lowest Area (% of total land area) in 1993?
Offer a terse response. 65.55. 